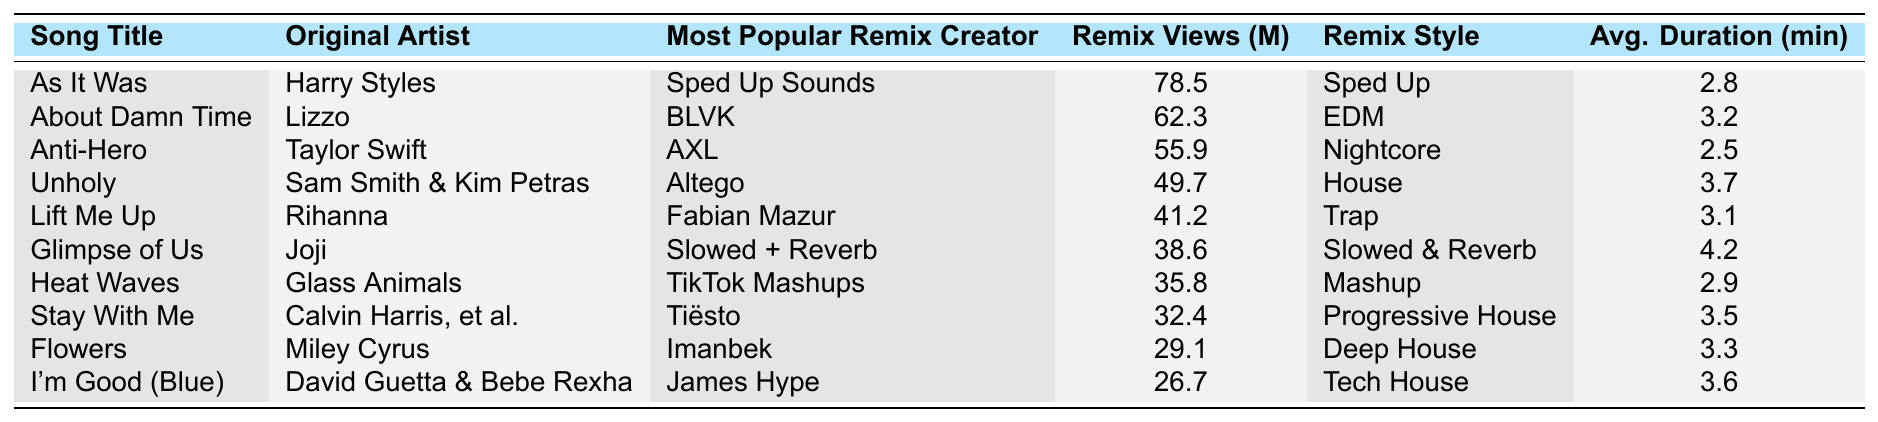What's the song with the highest remix views? The table shows all the songs and their remix views. By scanning the "Remix Views" column, "As It Was" has the highest views at 78.5 million.
Answer: As It Was Who is the original artist of "Glimpse of Us"? The table lists each song along with its original artist. For "Glimpse of Us," the original artist is Joji.
Answer: Joji How many views (in millions) did the remix of "Lift Me Up" receive? The "Remix Views" column indicates that "Lift Me Up," remixed by Fabian Mazur, has 41.2 million views.
Answer: 41.2 What is the average remix duration for "Stay With Me"? Looking at the table, the average duration for the remix of "Stay With Me" is 3.5 minutes.
Answer: 3.5 Which song has the longest average remix duration? To find out, we compare the "Average Remix Duration" column. "Glimpse of Us" has the longest duration at 4.2 minutes.
Answer: Glimpse of Us Is the most popular remix creator for "Anti-Hero" the same as for "About Damn Time"? Checking the "Most Popular Remix Creator" column, "Anti-Hero" is by AXL, while "About Damn Time" is by BLVK. They are different creators.
Answer: No How many total views do the remixes of "Flowers" and "I'm Good (Blue)" have combined? Summing the views from the "Remix Views" column: 29.1 (Flowers) + 26.7 (I'm Good (Blue)) = 55.8 million.
Answer: 55.8 Which remix style is used for "Unholy"? The "Remix Style" column shows that "Unholy" falls under the "House" genre.
Answer: House How many remixes have more than 50 million views? By examining the "Remix Views" column, three songs exceed 50 million views: "As It Was," "About Damn Time," and "Anti-Hero." Therefore, there are three in total.
Answer: 3 Which original artist has the highest number of views from their remixed songs? Analyzing the total views: Harry Styles (78.5), Lizzo (62.3), Taylor Swift (55.9), Sam Smith & Kim Petras (49.7), Rihanna (41.2), Joji (38.6), Glass Animals (35.8), Calvin Harris, et al. (32.4), Miley Cyrus (29.1), David Guetta & Bebe Rexha (26.7). Harry Styles has the highest total views with 78.5 million.
Answer: Harry Styles 